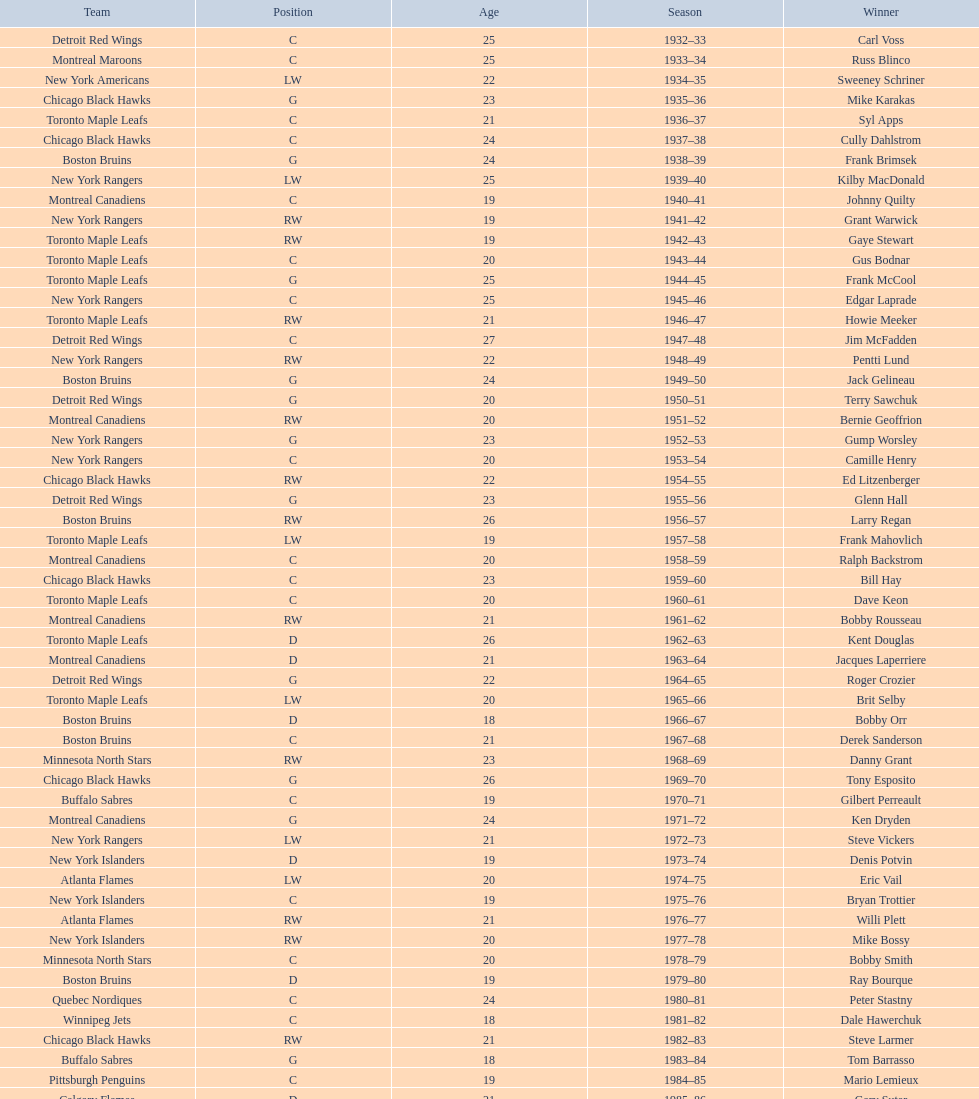Which team has the highest number of consecutive calder memorial trophy winners? Toronto Maple Leafs. Write the full table. {'header': ['Team', 'Position', 'Age', 'Season', 'Winner'], 'rows': [['Detroit Red Wings', 'C', '25', '1932–33', 'Carl Voss'], ['Montreal Maroons', 'C', '25', '1933–34', 'Russ Blinco'], ['New York Americans', 'LW', '22', '1934–35', 'Sweeney Schriner'], ['Chicago Black Hawks', 'G', '23', '1935–36', 'Mike Karakas'], ['Toronto Maple Leafs', 'C', '21', '1936–37', 'Syl Apps'], ['Chicago Black Hawks', 'C', '24', '1937–38', 'Cully Dahlstrom'], ['Boston Bruins', 'G', '24', '1938–39', 'Frank Brimsek'], ['New York Rangers', 'LW', '25', '1939–40', 'Kilby MacDonald'], ['Montreal Canadiens', 'C', '19', '1940–41', 'Johnny Quilty'], ['New York Rangers', 'RW', '19', '1941–42', 'Grant Warwick'], ['Toronto Maple Leafs', 'RW', '19', '1942–43', 'Gaye Stewart'], ['Toronto Maple Leafs', 'C', '20', '1943–44', 'Gus Bodnar'], ['Toronto Maple Leafs', 'G', '25', '1944–45', 'Frank McCool'], ['New York Rangers', 'C', '25', '1945–46', 'Edgar Laprade'], ['Toronto Maple Leafs', 'RW', '21', '1946–47', 'Howie Meeker'], ['Detroit Red Wings', 'C', '27', '1947–48', 'Jim McFadden'], ['New York Rangers', 'RW', '22', '1948–49', 'Pentti Lund'], ['Boston Bruins', 'G', '24', '1949–50', 'Jack Gelineau'], ['Detroit Red Wings', 'G', '20', '1950–51', 'Terry Sawchuk'], ['Montreal Canadiens', 'RW', '20', '1951–52', 'Bernie Geoffrion'], ['New York Rangers', 'G', '23', '1952–53', 'Gump Worsley'], ['New York Rangers', 'C', '20', '1953–54', 'Camille Henry'], ['Chicago Black Hawks', 'RW', '22', '1954–55', 'Ed Litzenberger'], ['Detroit Red Wings', 'G', '23', '1955–56', 'Glenn Hall'], ['Boston Bruins', 'RW', '26', '1956–57', 'Larry Regan'], ['Toronto Maple Leafs', 'LW', '19', '1957–58', 'Frank Mahovlich'], ['Montreal Canadiens', 'C', '20', '1958–59', 'Ralph Backstrom'], ['Chicago Black Hawks', 'C', '23', '1959–60', 'Bill Hay'], ['Toronto Maple Leafs', 'C', '20', '1960–61', 'Dave Keon'], ['Montreal Canadiens', 'RW', '21', '1961–62', 'Bobby Rousseau'], ['Toronto Maple Leafs', 'D', '26', '1962–63', 'Kent Douglas'], ['Montreal Canadiens', 'D', '21', '1963–64', 'Jacques Laperriere'], ['Detroit Red Wings', 'G', '22', '1964–65', 'Roger Crozier'], ['Toronto Maple Leafs', 'LW', '20', '1965–66', 'Brit Selby'], ['Boston Bruins', 'D', '18', '1966–67', 'Bobby Orr'], ['Boston Bruins', 'C', '21', '1967–68', 'Derek Sanderson'], ['Minnesota North Stars', 'RW', '23', '1968–69', 'Danny Grant'], ['Chicago Black Hawks', 'G', '26', '1969–70', 'Tony Esposito'], ['Buffalo Sabres', 'C', '19', '1970–71', 'Gilbert Perreault'], ['Montreal Canadiens', 'G', '24', '1971–72', 'Ken Dryden'], ['New York Rangers', 'LW', '21', '1972–73', 'Steve Vickers'], ['New York Islanders', 'D', '19', '1973–74', 'Denis Potvin'], ['Atlanta Flames', 'LW', '20', '1974–75', 'Eric Vail'], ['New York Islanders', 'C', '19', '1975–76', 'Bryan Trottier'], ['Atlanta Flames', 'RW', '21', '1976–77', 'Willi Plett'], ['New York Islanders', 'RW', '20', '1977–78', 'Mike Bossy'], ['Minnesota North Stars', 'C', '20', '1978–79', 'Bobby Smith'], ['Boston Bruins', 'D', '19', '1979–80', 'Ray Bourque'], ['Quebec Nordiques', 'C', '24', '1980–81', 'Peter Stastny'], ['Winnipeg Jets', 'C', '18', '1981–82', 'Dale Hawerchuk'], ['Chicago Black Hawks', 'RW', '21', '1982–83', 'Steve Larmer'], ['Buffalo Sabres', 'G', '18', '1983–84', 'Tom Barrasso'], ['Pittsburgh Penguins', 'C', '19', '1984–85', 'Mario Lemieux'], ['Calgary Flames', 'D', '21', '1985–86', 'Gary Suter'], ['Los Angeles Kings', 'LW', '20', '1986–87', 'Luc Robitaille'], ['Calgary Flames', 'C', '21', '1987–88', 'Joe Nieuwendyk'], ['New York Rangers', 'D', '20', '1988–89', 'Brian Leetch'], ['Calgary Flames', 'RW', '31', '1989–90', 'Sergei Makarov'], ['Chicago Blackhawks', 'G', '25', '1990–91', 'Ed Belfour'], ['Vancouver Canucks', 'RW', '20', '1991–92', 'Pavel Bure'], ['Winnipeg Jets', 'RW', '22', '1992–93', 'Teemu Selanne'], ['New Jersey Devils', 'G', '21', '1993–94', 'Martin Brodeur'], ['Quebec Nordiques', 'C', '21', '1994–95', 'Peter Forsberg'], ['Ottawa Senators', 'RW', '22', '1995–96', 'Daniel Alfredsson'], ['New York Islanders', 'D', '19', '1996–97', 'Bryan Berard'], ['Boston Bruins', 'LW', '19', '1997–98', 'Sergei Samsonov'], ['Colorado Avalanche', 'C', '22', '1998–99', 'Chris Drury'], ['New Jersey Devils', 'C', '19', '1999–2000', 'Scott Gomez'], ['San Jose Sharks', 'G', '25', '2000–01', 'Evgeni Nabokov'], ['Atlanta Thrashers', 'RW', '20', '2001–02', 'Dany Heatley'], ['St. Louis Blues', 'D', '21', '2002–03', 'Barret Jackman'], ['Boston Bruins', 'G', '23', '2003–04', 'Andrew Raycroft'], ['-', '-', '-', '2004–05', 'No winner because of the\\n2004–05 NHL lockout'], ['Washington Capitals', 'LW', '20', '2005–06', 'Alexander Ovechkin'], ['Pittsburgh Penguins', 'C', '20', '2006–07', 'Evgeni Malkin'], ['Chicago Blackhawks', 'RW', '19', '2007–08', 'Patrick Kane'], ['Columbus Blue Jackets', 'G', '21', '2008–09', 'Steve Mason'], ['Buffalo Sabres', 'D', '20', '2009–10', 'Tyler Myers'], ['Carolina Hurricanes', 'C', '18', '2010–11', 'Jeff Skinner'], ['Colorado Avalanche', 'LW', '19', '2011–12', 'Gabriel Landeskog'], ['Florida Panthers', 'C', '19', '2012–13', 'Jonathan Huberdeau']]} 